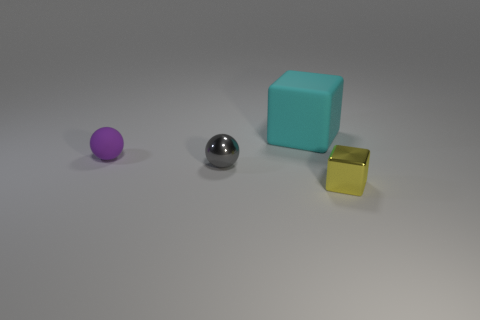Add 1 large purple rubber things. How many objects exist? 5 Add 4 purple rubber balls. How many purple rubber balls are left? 5 Add 3 small brown balls. How many small brown balls exist? 3 Subtract 0 yellow cylinders. How many objects are left? 4 Subtract all large metallic objects. Subtract all tiny rubber objects. How many objects are left? 3 